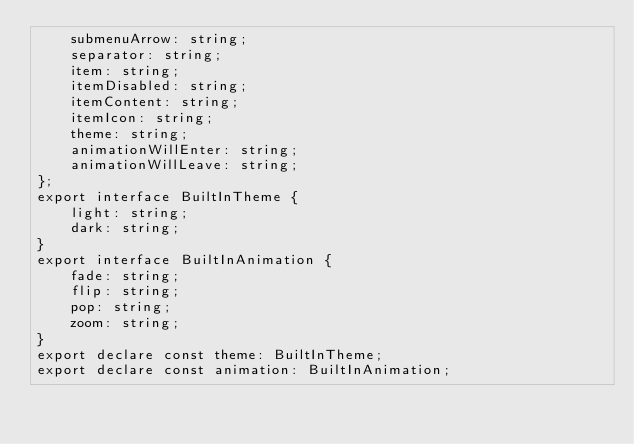Convert code to text. <code><loc_0><loc_0><loc_500><loc_500><_TypeScript_>    submenuArrow: string;
    separator: string;
    item: string;
    itemDisabled: string;
    itemContent: string;
    itemIcon: string;
    theme: string;
    animationWillEnter: string;
    animationWillLeave: string;
};
export interface BuiltInTheme {
    light: string;
    dark: string;
}
export interface BuiltInAnimation {
    fade: string;
    flip: string;
    pop: string;
    zoom: string;
}
export declare const theme: BuiltInTheme;
export declare const animation: BuiltInAnimation;
</code> 